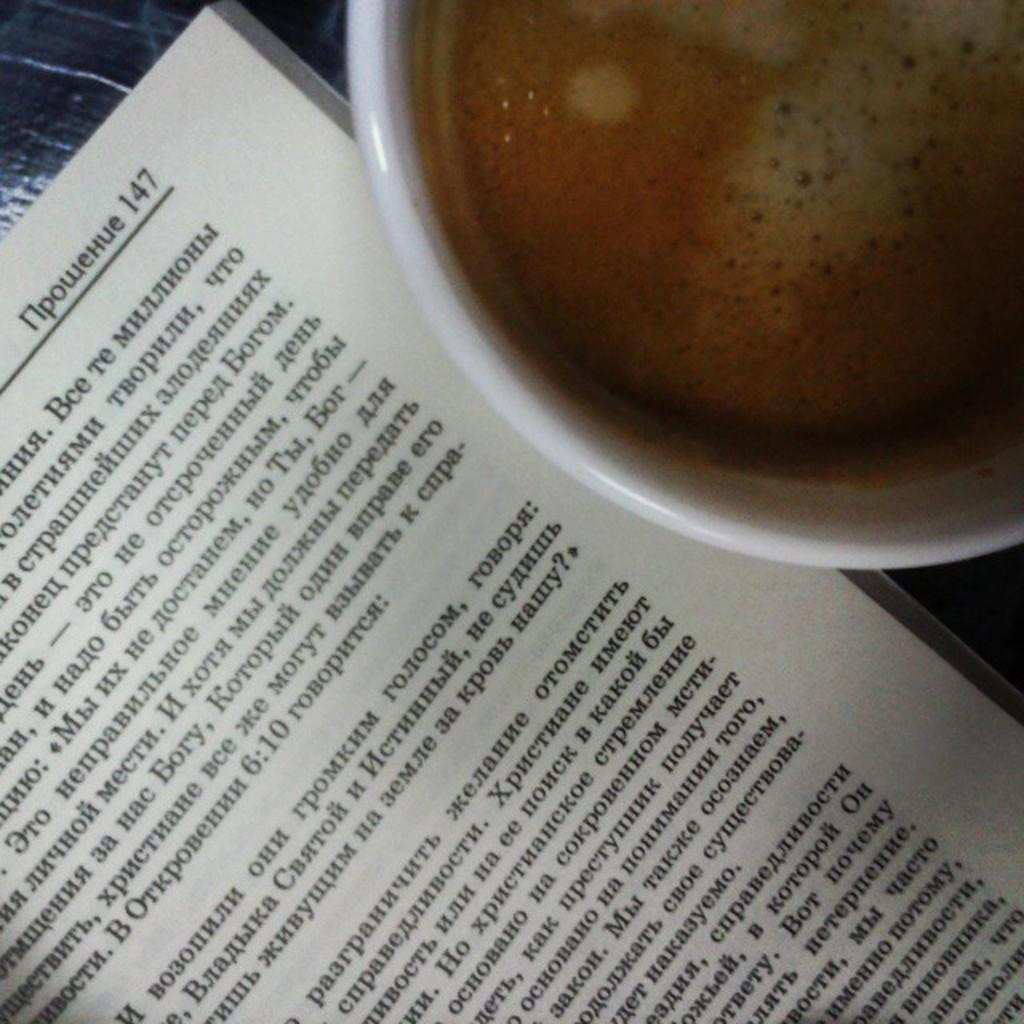<image>
Render a clear and concise summary of the photo. A book placed next to a drink, with the book having foreign writing. 